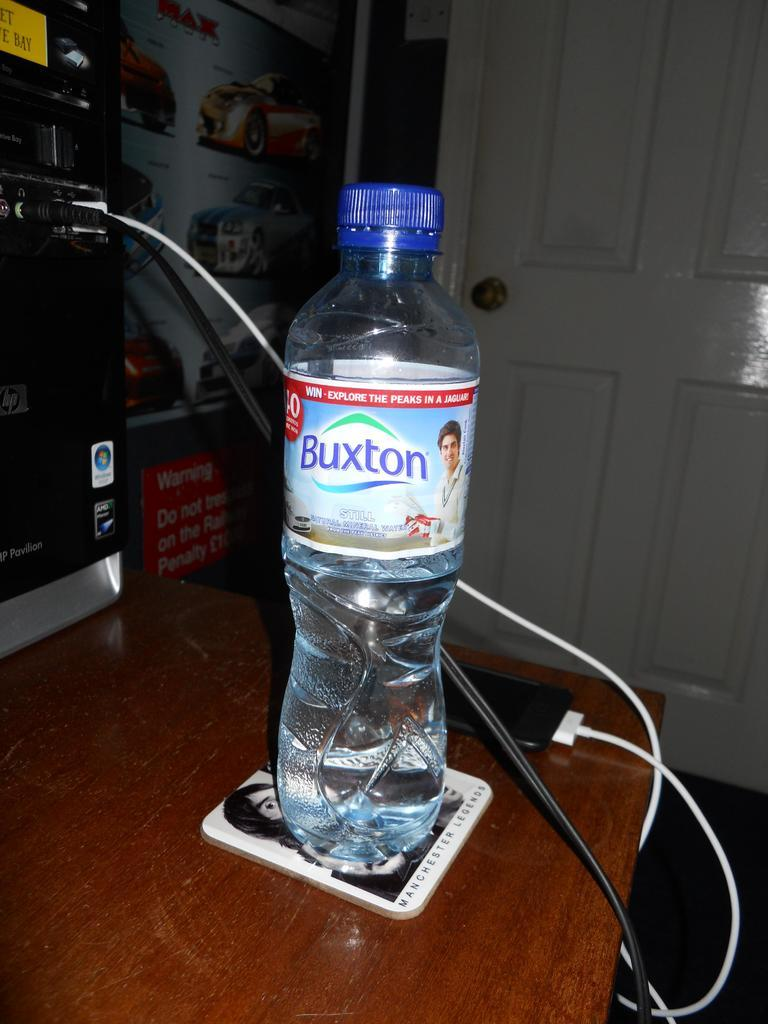<image>
Provide a brief description of the given image. A bottle of Buxton water sits on a desk 